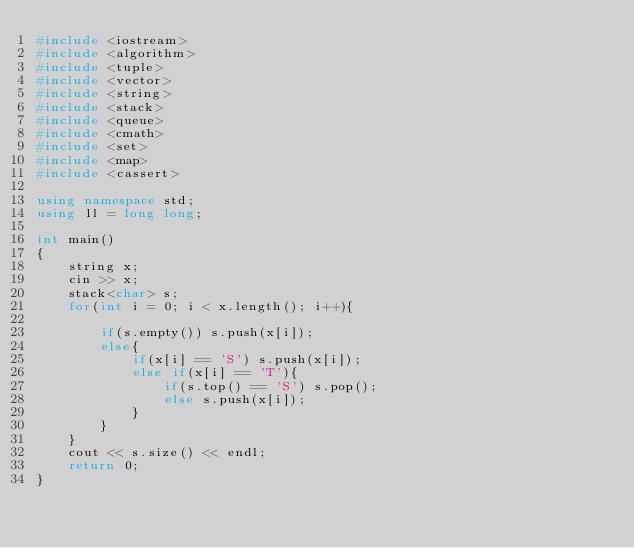<code> <loc_0><loc_0><loc_500><loc_500><_C++_>#include <iostream>
#include <algorithm>
#include <tuple>
#include <vector>
#include <string>
#include <stack>
#include <queue>
#include <cmath>
#include <set>
#include <map>
#include <cassert>

using namespace std;
using ll = long long;

int main()
{
    string x;
    cin >> x;
    stack<char> s;
    for(int i = 0; i < x.length(); i++){

        if(s.empty()) s.push(x[i]);
        else{
            if(x[i] == 'S') s.push(x[i]);
            else if(x[i] == 'T'){
                if(s.top() == 'S') s.pop();
                else s.push(x[i]);
            }
        }
    }
    cout << s.size() << endl;
    return 0;
}</code> 